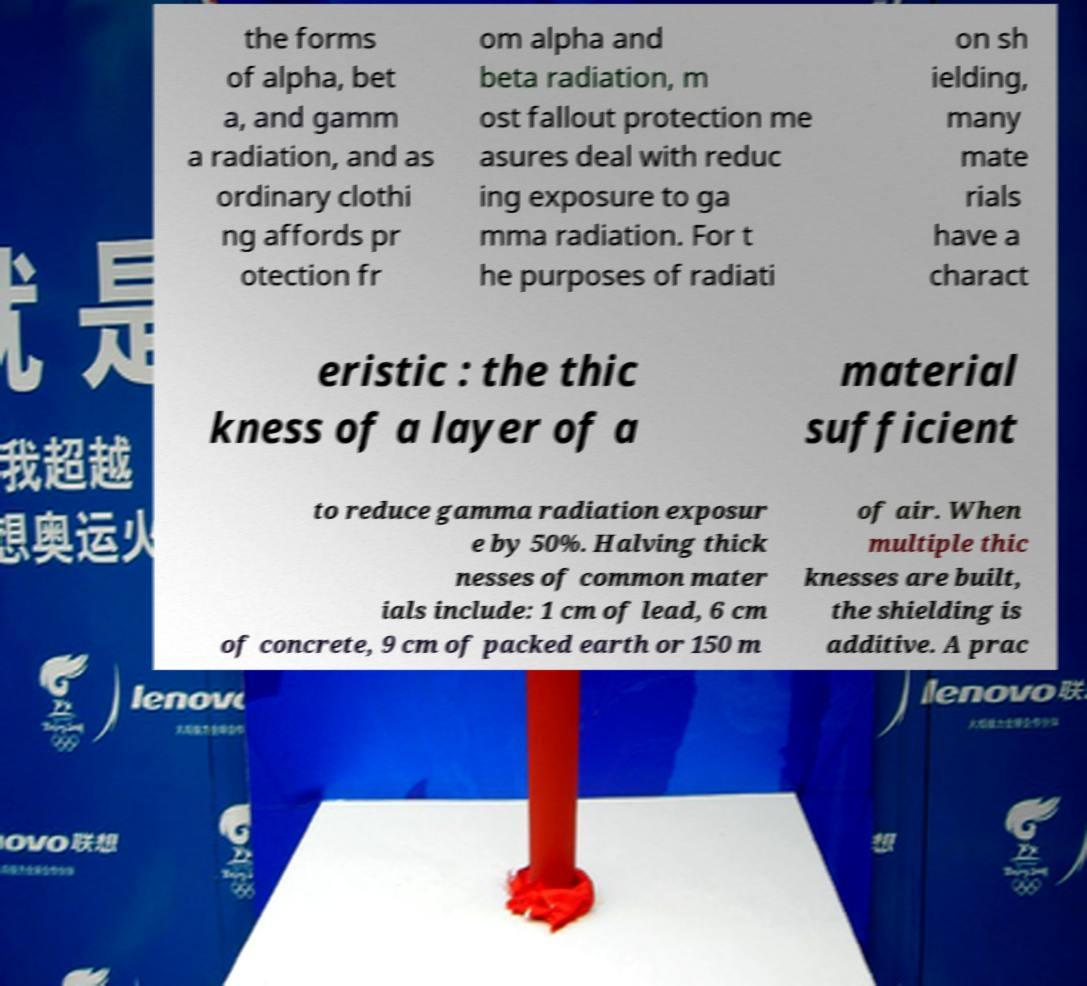Could you extract and type out the text from this image? the forms of alpha, bet a, and gamm a radiation, and as ordinary clothi ng affords pr otection fr om alpha and beta radiation, m ost fallout protection me asures deal with reduc ing exposure to ga mma radiation. For t he purposes of radiati on sh ielding, many mate rials have a charact eristic : the thic kness of a layer of a material sufficient to reduce gamma radiation exposur e by 50%. Halving thick nesses of common mater ials include: 1 cm of lead, 6 cm of concrete, 9 cm of packed earth or 150 m of air. When multiple thic knesses are built, the shielding is additive. A prac 